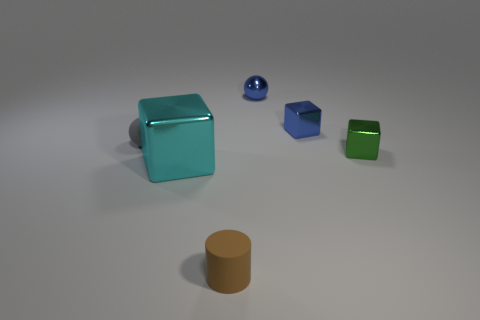What is the color of the tiny rubber object that is on the right side of the matte thing that is behind the tiny object to the right of the blue shiny cube?
Offer a terse response. Brown. Are any big cyan matte spheres visible?
Keep it short and to the point. No. What number of other things are the same size as the gray rubber sphere?
Your answer should be compact. 4. There is a metallic sphere; does it have the same color as the small metal cube that is to the left of the green metallic cube?
Keep it short and to the point. Yes. How many objects are green matte cubes or blue objects?
Your answer should be compact. 2. Is there any other thing that is the same color as the small metal sphere?
Ensure brevity in your answer.  Yes. Do the big object and the tiny cube left of the tiny green object have the same material?
Provide a short and direct response. Yes. The metal thing that is to the right of the block that is behind the tiny gray object is what shape?
Your answer should be compact. Cube. The thing that is to the right of the cyan block and in front of the small green object has what shape?
Your response must be concise. Cylinder. What number of things are cyan metallic objects or things that are in front of the gray matte ball?
Make the answer very short. 3. 